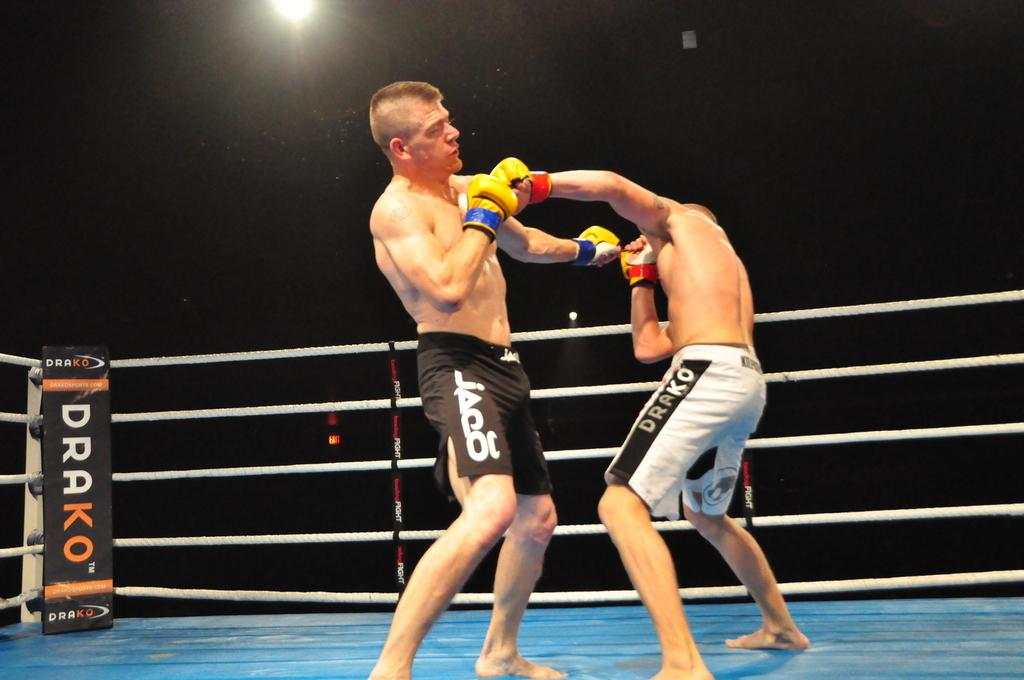<image>
Write a terse but informative summary of the picture. A man in white trunks with Drako on the side boxes with another man. 